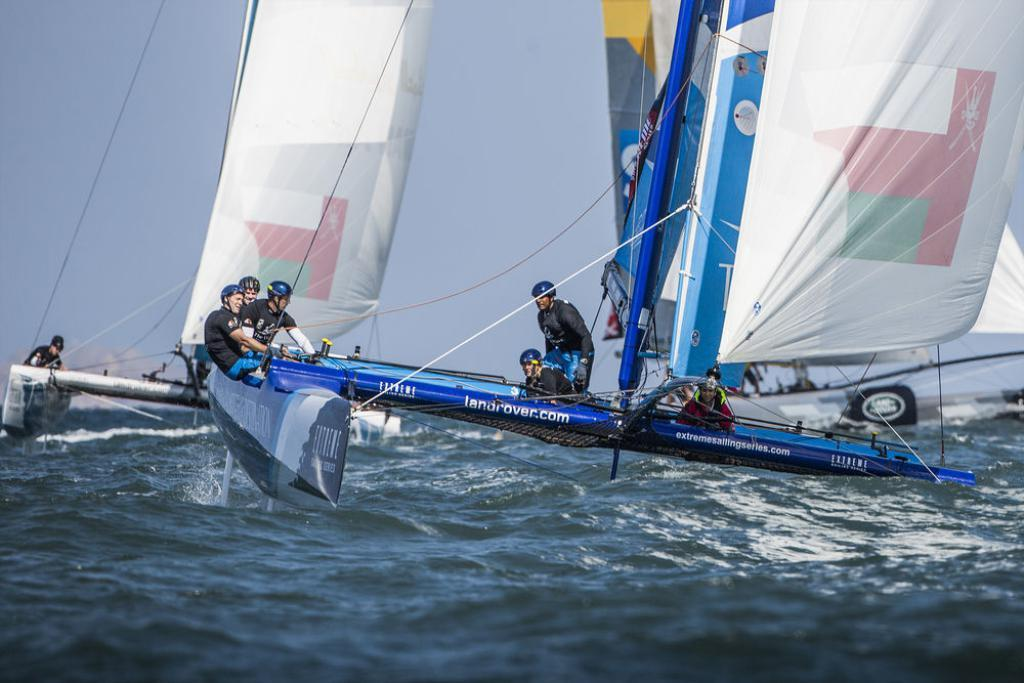What is on the water in the image? There are boats on the water in the image. Who or what is on the boats? There are people on the boats. What can be seen in the background of the image? The sky is visible in the background of the image. What is tied to the boats? Clothes are tied to the boats. Can you hear the tiger coughing in the image? There is no tiger or any sound mentioned in the image, so it is not possible to answer that question. 